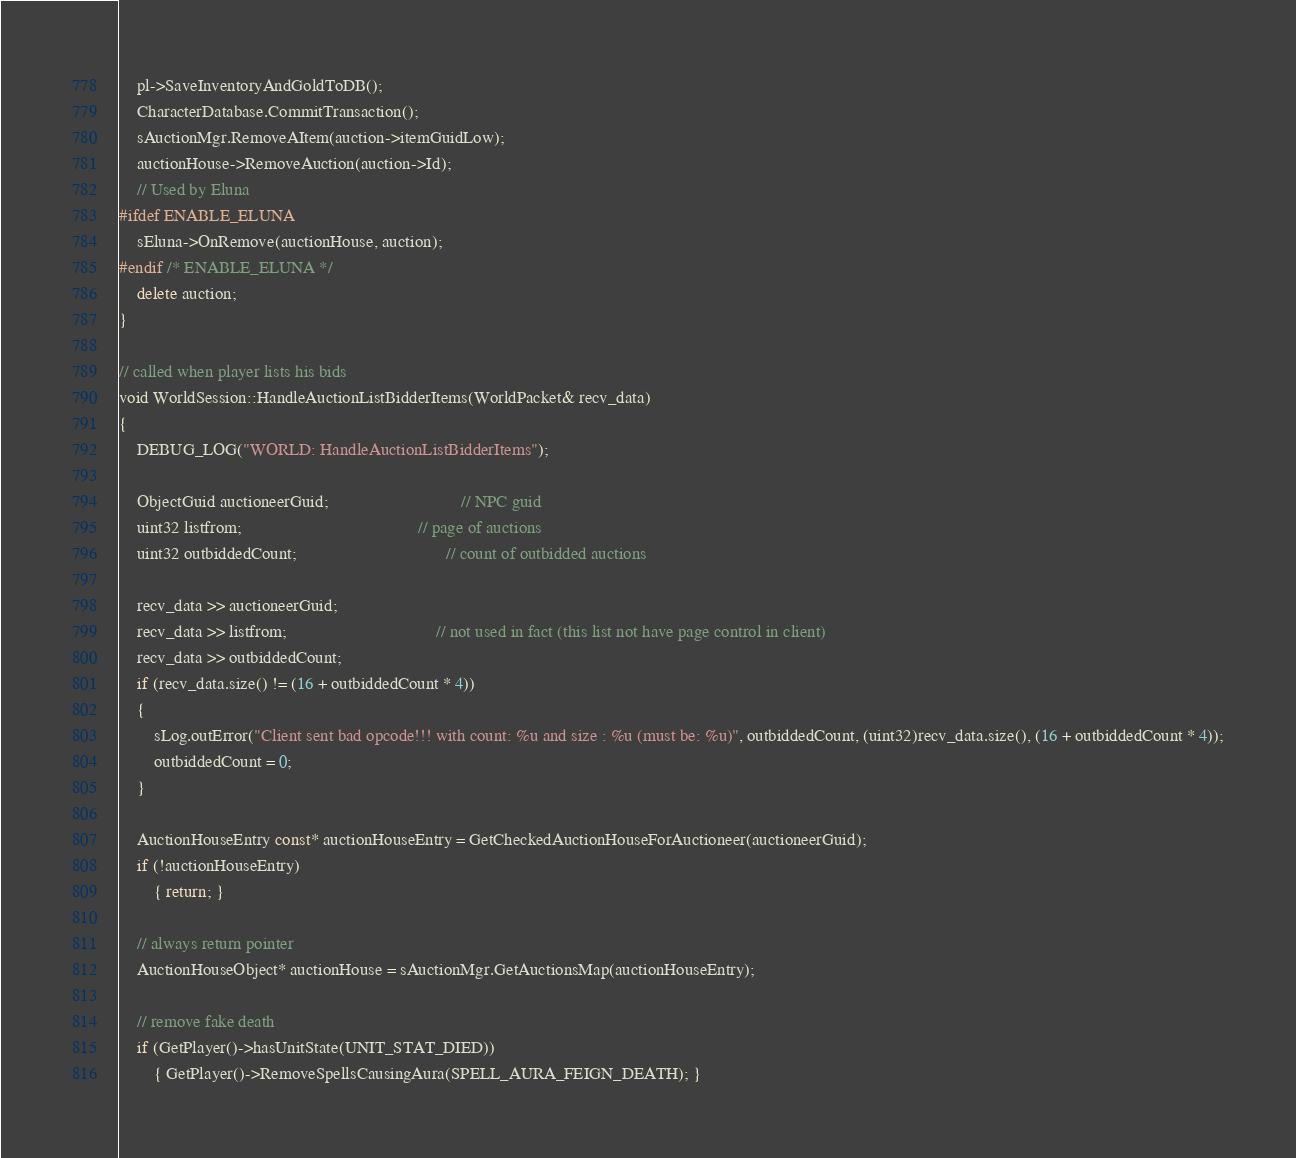Convert code to text. <code><loc_0><loc_0><loc_500><loc_500><_C++_>    pl->SaveInventoryAndGoldToDB();
    CharacterDatabase.CommitTransaction();
    sAuctionMgr.RemoveAItem(auction->itemGuidLow);
    auctionHouse->RemoveAuction(auction->Id);
    // Used by Eluna
#ifdef ENABLE_ELUNA
    sEluna->OnRemove(auctionHouse, auction);
#endif /* ENABLE_ELUNA */
    delete auction;
}

// called when player lists his bids
void WorldSession::HandleAuctionListBidderItems(WorldPacket& recv_data)
{
    DEBUG_LOG("WORLD: HandleAuctionListBidderItems");

    ObjectGuid auctioneerGuid;                              // NPC guid
    uint32 listfrom;                                        // page of auctions
    uint32 outbiddedCount;                                  // count of outbidded auctions

    recv_data >> auctioneerGuid;
    recv_data >> listfrom;                                  // not used in fact (this list not have page control in client)
    recv_data >> outbiddedCount;
    if (recv_data.size() != (16 + outbiddedCount * 4))
    {
        sLog.outError("Client sent bad opcode!!! with count: %u and size : %u (must be: %u)", outbiddedCount, (uint32)recv_data.size(), (16 + outbiddedCount * 4));
        outbiddedCount = 0;
    }

    AuctionHouseEntry const* auctionHouseEntry = GetCheckedAuctionHouseForAuctioneer(auctioneerGuid);
    if (!auctionHouseEntry)
        { return; }

    // always return pointer
    AuctionHouseObject* auctionHouse = sAuctionMgr.GetAuctionsMap(auctionHouseEntry);

    // remove fake death
    if (GetPlayer()->hasUnitState(UNIT_STAT_DIED))
        { GetPlayer()->RemoveSpellsCausingAura(SPELL_AURA_FEIGN_DEATH); }
</code> 